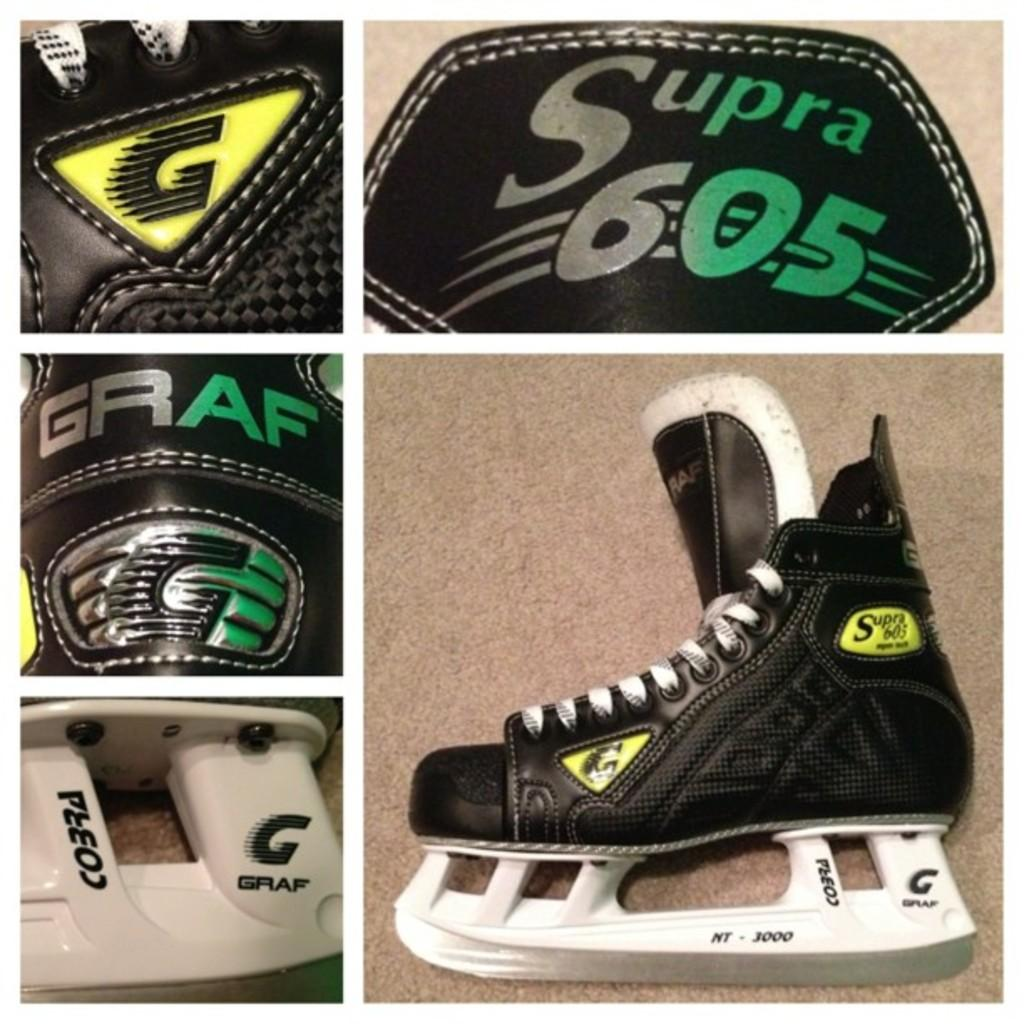What type of establishment is depicted in the image? The image is of a college. Can you describe any specific objects or items in the image? There is a black color shoe in the image. What type of pickle is being discussed by the students in the image? There is no indication of students or a discussion about pickles in the image. 